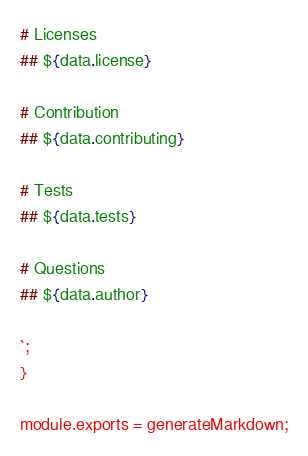Convert code to text. <code><loc_0><loc_0><loc_500><loc_500><_JavaScript_>
# Licenses
## ${data.license}

# Contribution
## ${data.contributing}

# Tests 
## ${data.tests}

# Questions
## ${data.author}

`;
}

module.exports = generateMarkdown;
</code> 